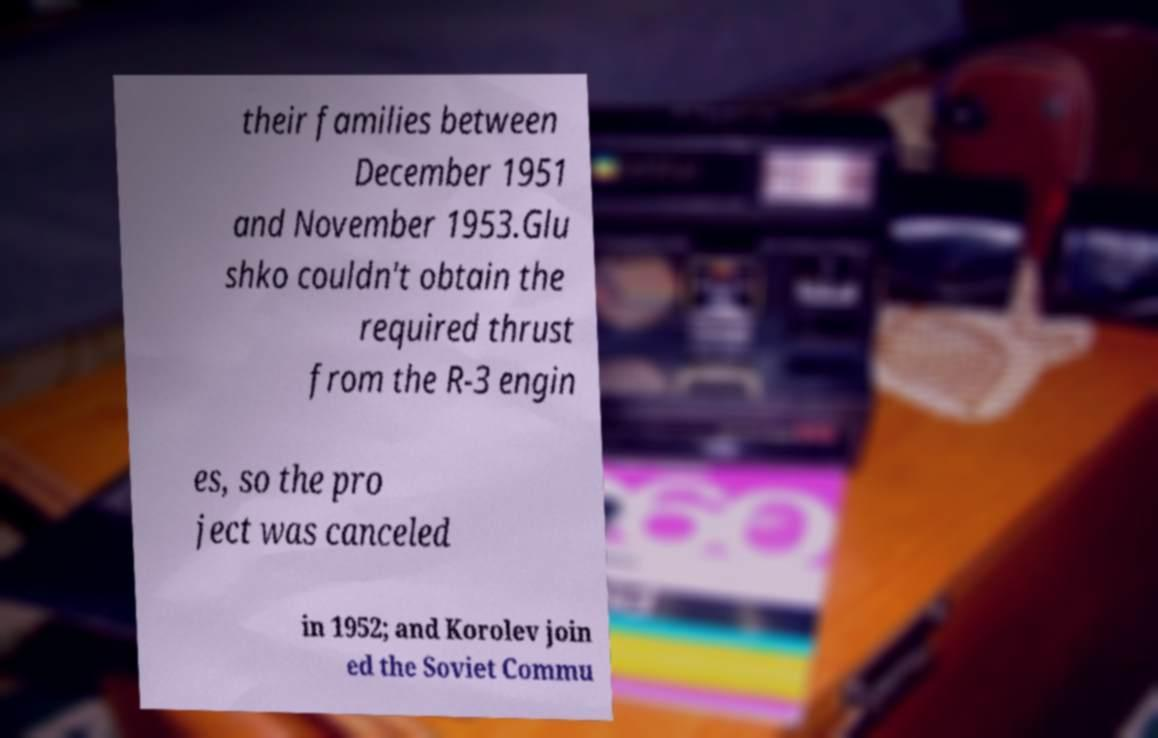There's text embedded in this image that I need extracted. Can you transcribe it verbatim? their families between December 1951 and November 1953.Glu shko couldn't obtain the required thrust from the R-3 engin es, so the pro ject was canceled in 1952; and Korolev join ed the Soviet Commu 